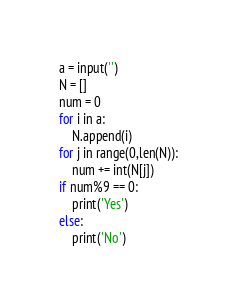<code> <loc_0><loc_0><loc_500><loc_500><_Python_>a = input('')
N = []
num = 0
for i in a:
    N.append(i)
for j in range(0,len(N)):
    num += int(N[j])
if num%9 == 0:
    print('Yes')
else:
    print('No')</code> 